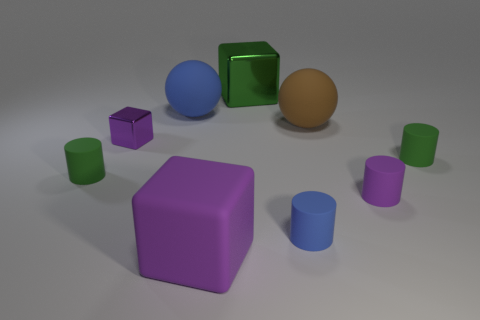How many other objects are there of the same shape as the tiny blue object?
Offer a terse response. 3. Do the big block in front of the blue cylinder and the small cube have the same color?
Offer a terse response. Yes. How many other objects are the same size as the brown matte thing?
Give a very brief answer. 3. Is the material of the brown object the same as the green block?
Provide a succinct answer. No. There is a large cube that is in front of the small matte cylinder that is to the right of the tiny purple matte object; what color is it?
Make the answer very short. Purple. There is another matte object that is the same shape as the brown object; what is its size?
Your response must be concise. Large. Is the matte cube the same color as the small metal object?
Ensure brevity in your answer.  Yes. What number of metallic blocks are in front of the tiny green matte object that is right of the block to the left of the rubber block?
Your answer should be compact. 0. Are there more tiny purple cylinders than tiny brown objects?
Keep it short and to the point. Yes. What number of small red blocks are there?
Keep it short and to the point. 0. 